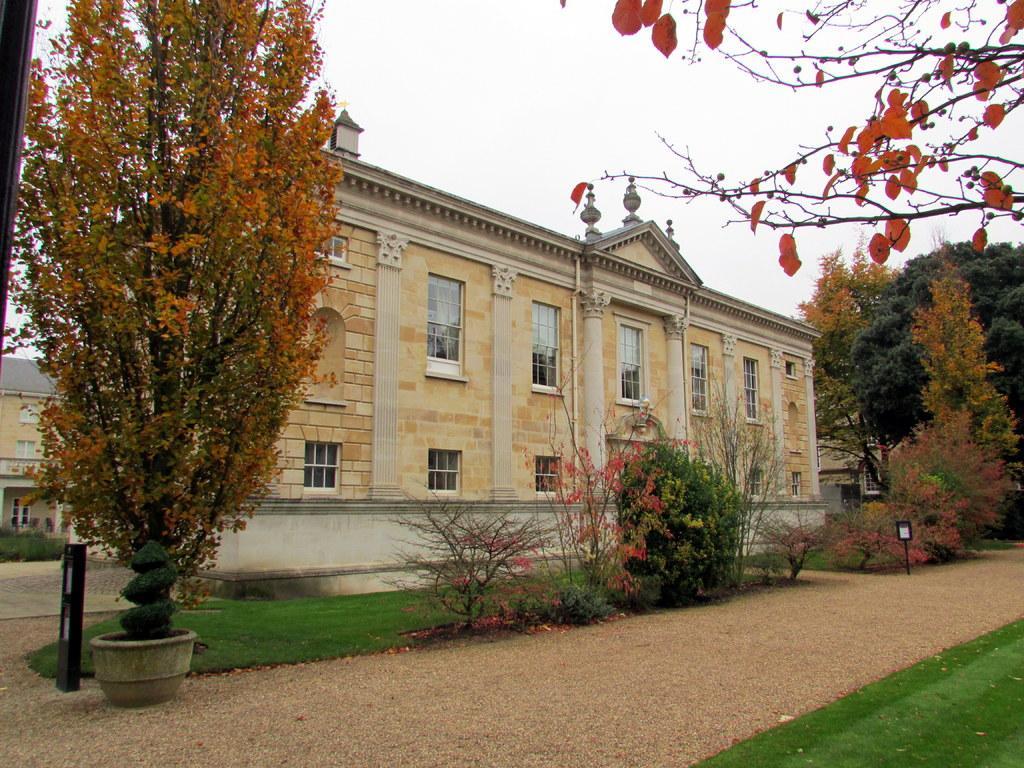How would you summarize this image in a sentence or two? In this image in the front there's grass on the ground. In the center there are trees, there are poles, there is grass on the ground and in the background there are buildings, trees. 